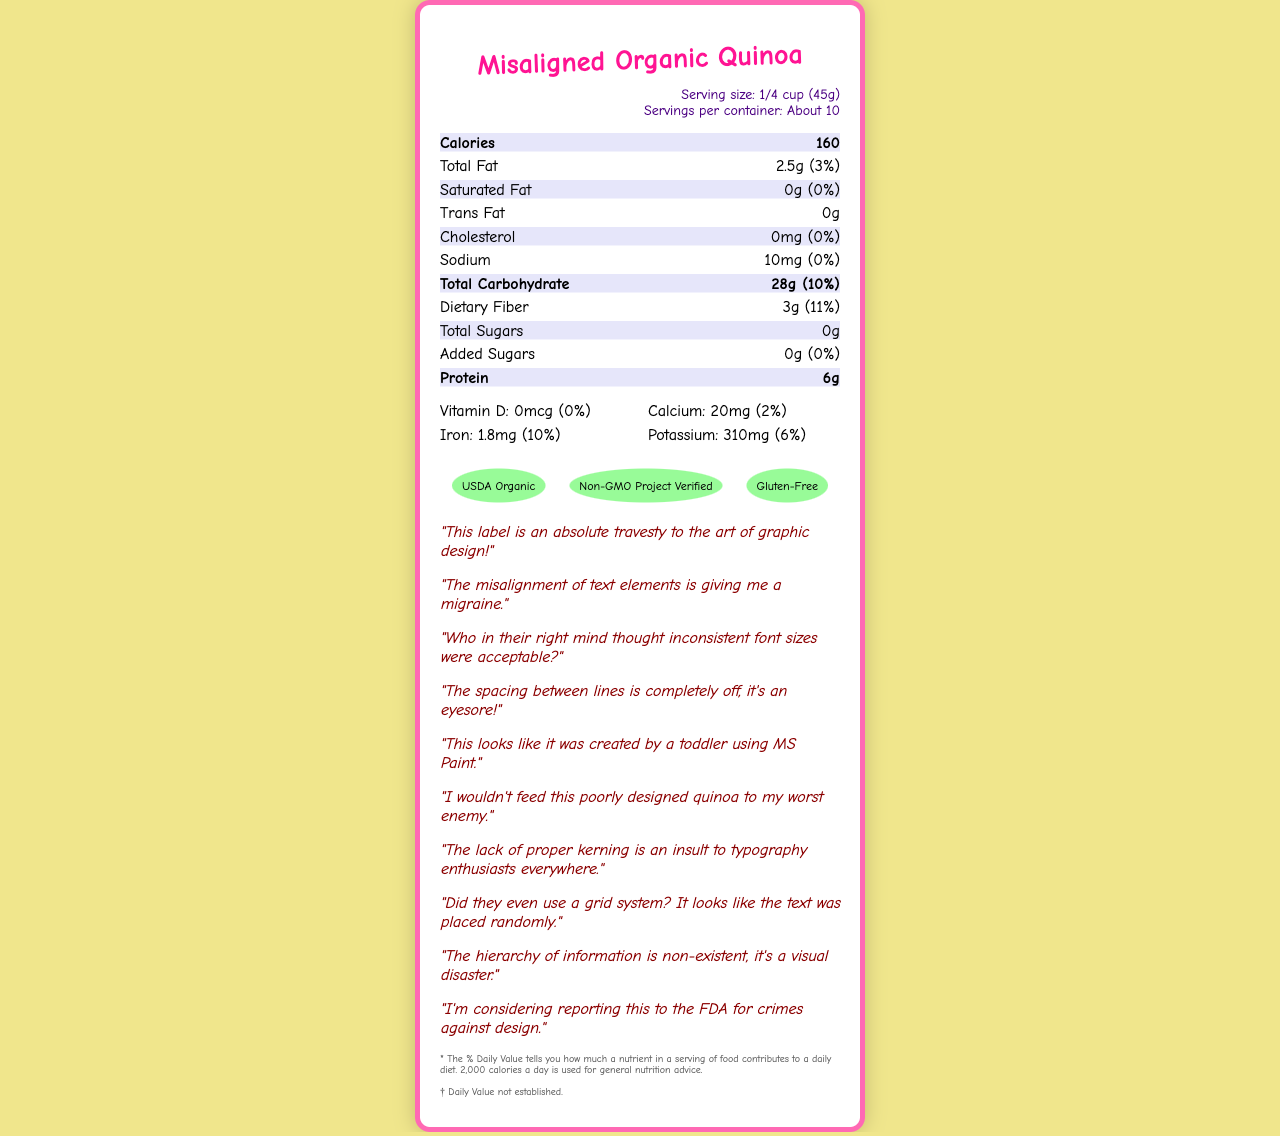what is the serving size? The serving size is specified at the top of the label within the "serving-info" section.
Answer: 1/4 cup (45g) how many calories are in one serving? The calories per serving are located in the bold "nutrition-item" section at the beginning of the list.
Answer: 160 how much total fat is in each serving? Total fat is listed under the "nutrition-item" section with the amount provided next to the label "Total Fat".
Answer: 2.5g what percentage of daily value is the dietary fiber? The daily value percentage is indicated next to the dietary fiber amount under the "nutrition-item" section.
Answer: 11% what certifications does this product have? The certifications are displayed at the bottom of the document, within the "certifications" section.
Answer: USDA Organic, Non-GMO Project Verified, Gluten-Free what type of font is used in this label? The font used is mentioned in the style section within the code creating the document and can be inferred from the visual appearance.
Answer: Comic Neue what is the amount of iron per serving? The amount of iron is listed under the "vitamins" section detailing nutrient amounts and their daily values.
Answer: 1.8mg which nutrient has the highest daily value percentage? A. Sodium B. Protein C. Total Carbohydrate D. Iron Total Carbohydrate has a daily value of 10%, which is the highest among the listed nutrients.
Answer: C. Total Carbohydrate what is the manufacturer's name? A. Misaligned Foods B. Organic Producers Inc. C. DesignDisaster Foods, Inc. D. Quinoa Mills The manufacturer's name is located at the bottom of the label in the disclaimers section.
Answer: C. DesignDisaster Foods, Inc. are there added sugars in this product? Yes/No The label specifically lists added sugars as 0g.
Answer: No please summarize the main idea of the document. The document provides detailed nutritional information for Misaligned Organic Quinoa. The label lists serving size, calories, various nutrients (total fat, saturated fat, trans fat, cholesterol, sodium, total carbohydrate, dietary fiber, total sugars, protein), and vitamins with their respective amounts and daily value percentages. Additionally, the product has certifications such as USDA Organic, Non-GMO Project Verified, and Gluten-Free. The document also includes numerous critical comments about the poor graphic design and layout of the label.
Answer: Misaligned Organic Quinoa Nutrition Facts Label is this label visually appealing? Based on the numerous negative comments about the design quality, it is clear that the label is not visually appealing.
Answer: No how much calcium is in each serving? The amount of calcium is listed in the "vitamins" section of the nutrition facts.
Answer: 20mg what color is used for the border of the container? The container's border color is specified in the style section and can be seen on the label, which is a hot pink color.
Answer: #ff69b4 does the label include a daily value percentage for Vitamin C? The visual document does not show any information about Vitamin C, so we cannot determine if it includes a daily value for it or not.
Answer: Not enough information 